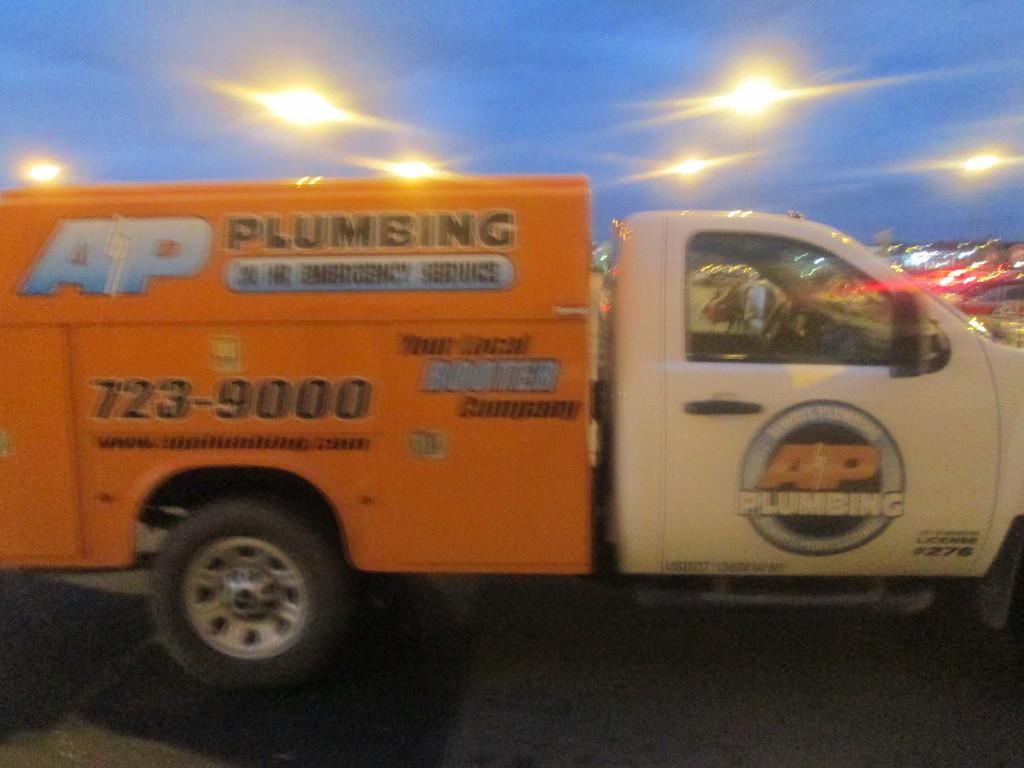What is the main subject in the center of the image? There is a van in the center of the image. Can you describe any additional features of the van? The provided facts do not mention any additional features of the van. What can be seen at the top side of the image? There are lights at the top side of the image. What type of cheese is being served in the nation depicted in the image? There is no cheese or nation mentioned in the image, so it is not possible to answer that question. 